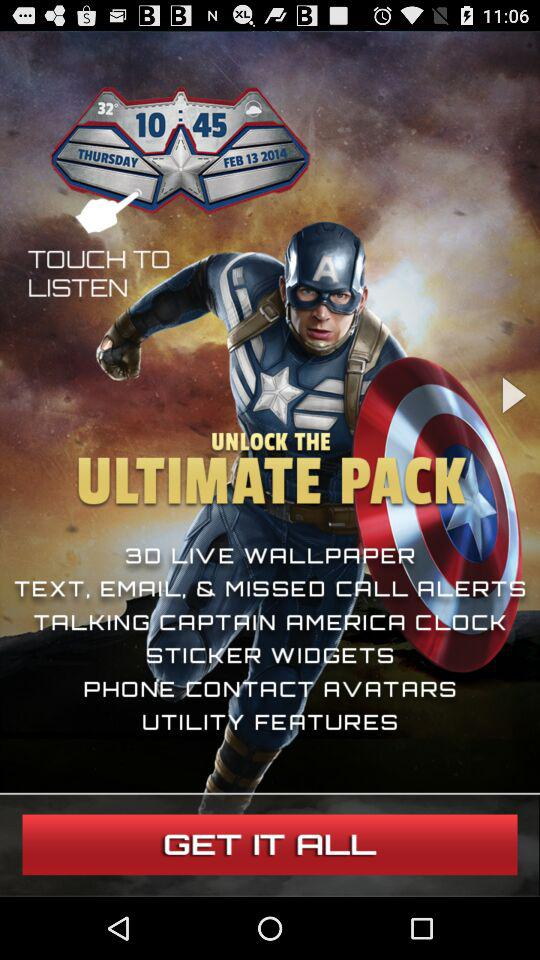What is the version of this application?
When the provided information is insufficient, respond with <no answer>. <no answer> 